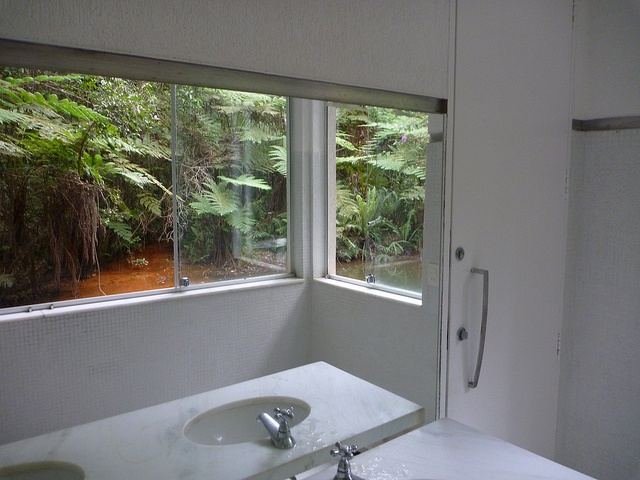Describe the objects in this image and their specific colors. I can see sink in gray tones and sink in gray and black tones in this image. 